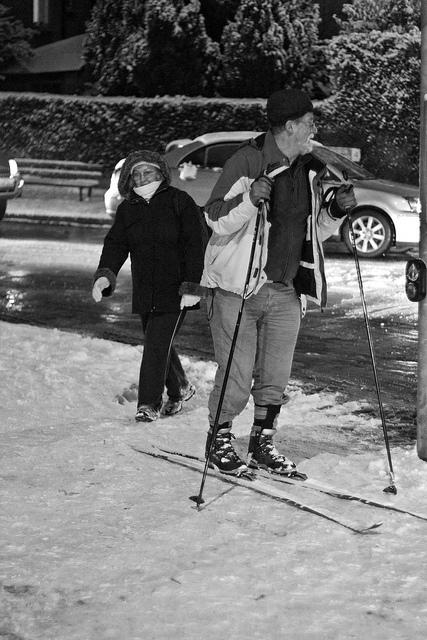Do these two people know each other?
Give a very brief answer. No. Is it snowing?
Write a very short answer. No. Is the man skiing on a sidewalk?
Keep it brief. Yes. How many people are wearing skiing gear in this photo?
Quick response, please. 1. 